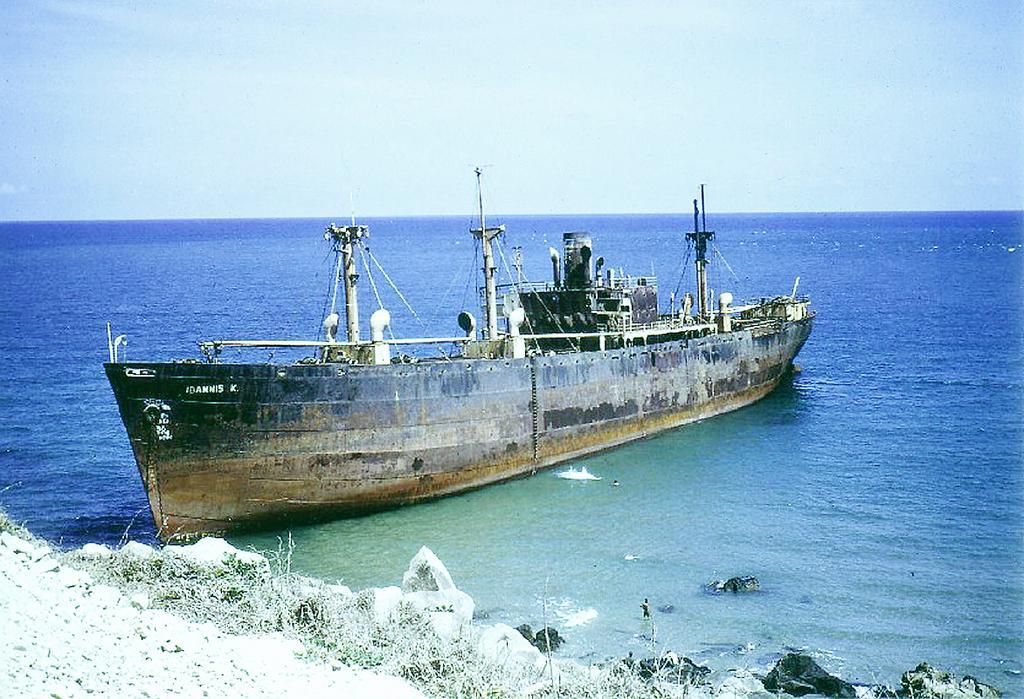In one or two sentences, can you explain what this image depicts? In this image we can see a ship is floating on the water. Here we can see rocks and grass and in the background, we can see the plain sky. 